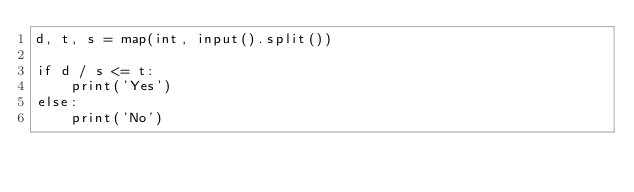Convert code to text. <code><loc_0><loc_0><loc_500><loc_500><_Python_>d, t, s = map(int, input().split())

if d / s <= t:
    print('Yes')
else:
    print('No')</code> 